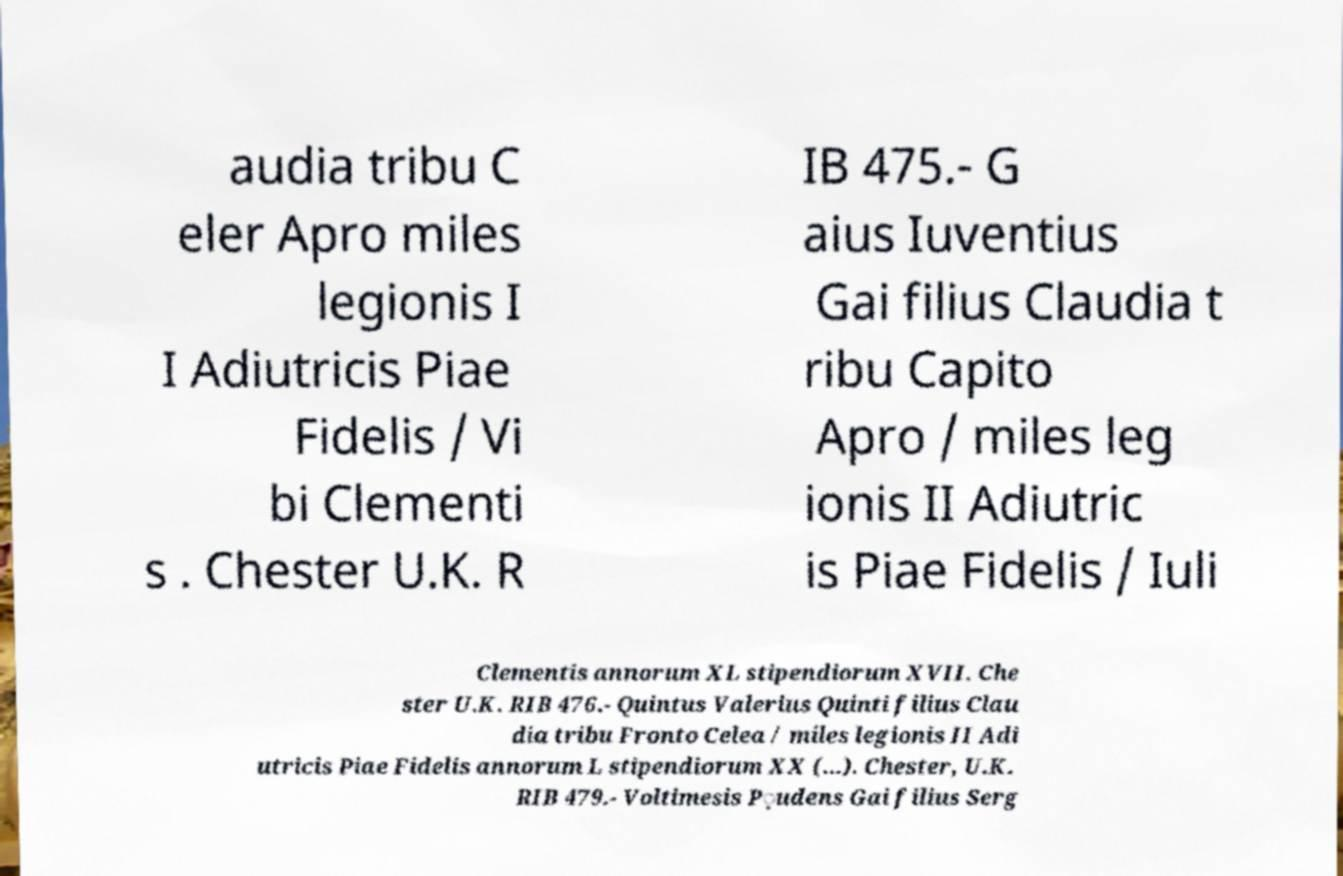Could you assist in decoding the text presented in this image and type it out clearly? audia tribu C eler Apro miles legionis I I Adiutricis Piae Fidelis / Vi bi Clementi s . Chester U.K. R IB 475.- G aius Iuventius Gai filius Claudia t ribu Capito Apro / miles leg ionis II Adiutric is Piae Fidelis / Iuli Clementis annorum XL stipendiorum XVII. Che ster U.K. RIB 476.- Quintus Valerius Quinti filius Clau dia tribu Fronto Celea / miles legionis II Adi utricis Piae Fidelis annorum L stipendiorum XX (...). Chester, U.K. RIB 479.- Voltimesis P̣udens Gai filius Serg 